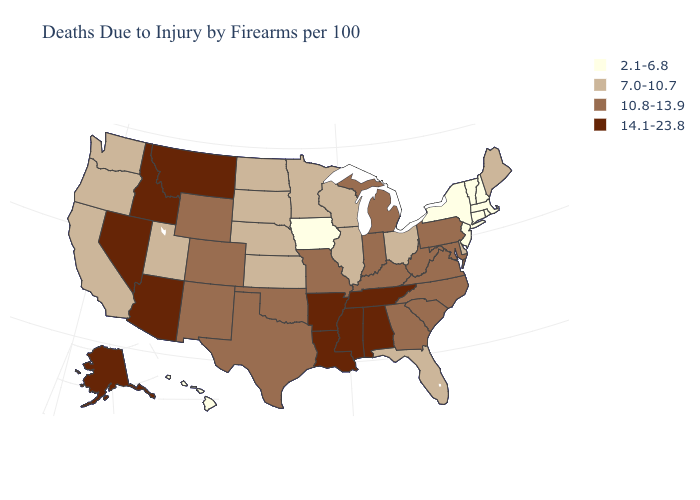Does Texas have a lower value than Alaska?
Keep it brief. Yes. Does the first symbol in the legend represent the smallest category?
Short answer required. Yes. Name the states that have a value in the range 14.1-23.8?
Be succinct. Alabama, Alaska, Arizona, Arkansas, Idaho, Louisiana, Mississippi, Montana, Nevada, Tennessee. Does Ohio have the lowest value in the MidWest?
Keep it brief. No. Among the states that border Minnesota , does North Dakota have the highest value?
Concise answer only. Yes. How many symbols are there in the legend?
Keep it brief. 4. Which states have the lowest value in the South?
Short answer required. Delaware, Florida. What is the highest value in states that border Wisconsin?
Quick response, please. 10.8-13.9. What is the value of Rhode Island?
Write a very short answer. 2.1-6.8. Which states have the highest value in the USA?
Give a very brief answer. Alabama, Alaska, Arizona, Arkansas, Idaho, Louisiana, Mississippi, Montana, Nevada, Tennessee. Name the states that have a value in the range 10.8-13.9?
Answer briefly. Colorado, Georgia, Indiana, Kentucky, Maryland, Michigan, Missouri, New Mexico, North Carolina, Oklahoma, Pennsylvania, South Carolina, Texas, Virginia, West Virginia, Wyoming. What is the value of Montana?
Write a very short answer. 14.1-23.8. Name the states that have a value in the range 10.8-13.9?
Be succinct. Colorado, Georgia, Indiana, Kentucky, Maryland, Michigan, Missouri, New Mexico, North Carolina, Oklahoma, Pennsylvania, South Carolina, Texas, Virginia, West Virginia, Wyoming. Name the states that have a value in the range 2.1-6.8?
Keep it brief. Connecticut, Hawaii, Iowa, Massachusetts, New Hampshire, New Jersey, New York, Rhode Island, Vermont. Which states have the lowest value in the South?
Be succinct. Delaware, Florida. 